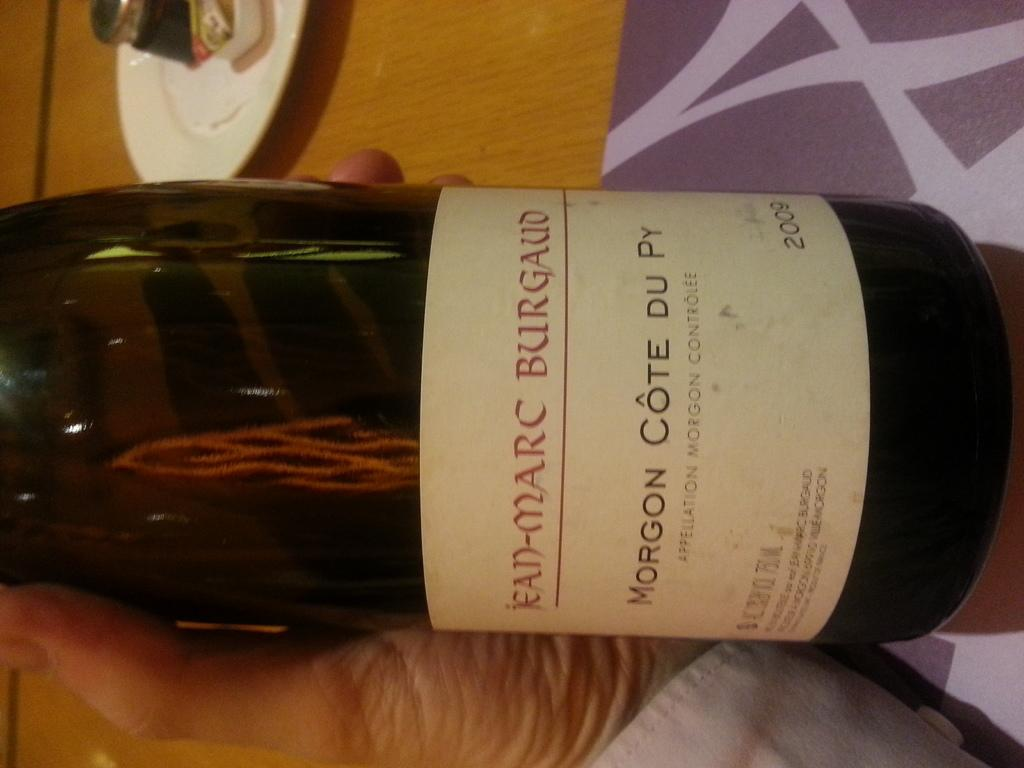Provide a one-sentence caption for the provided image. Someone holding a bottle of Morgon Cote Du over the table. 